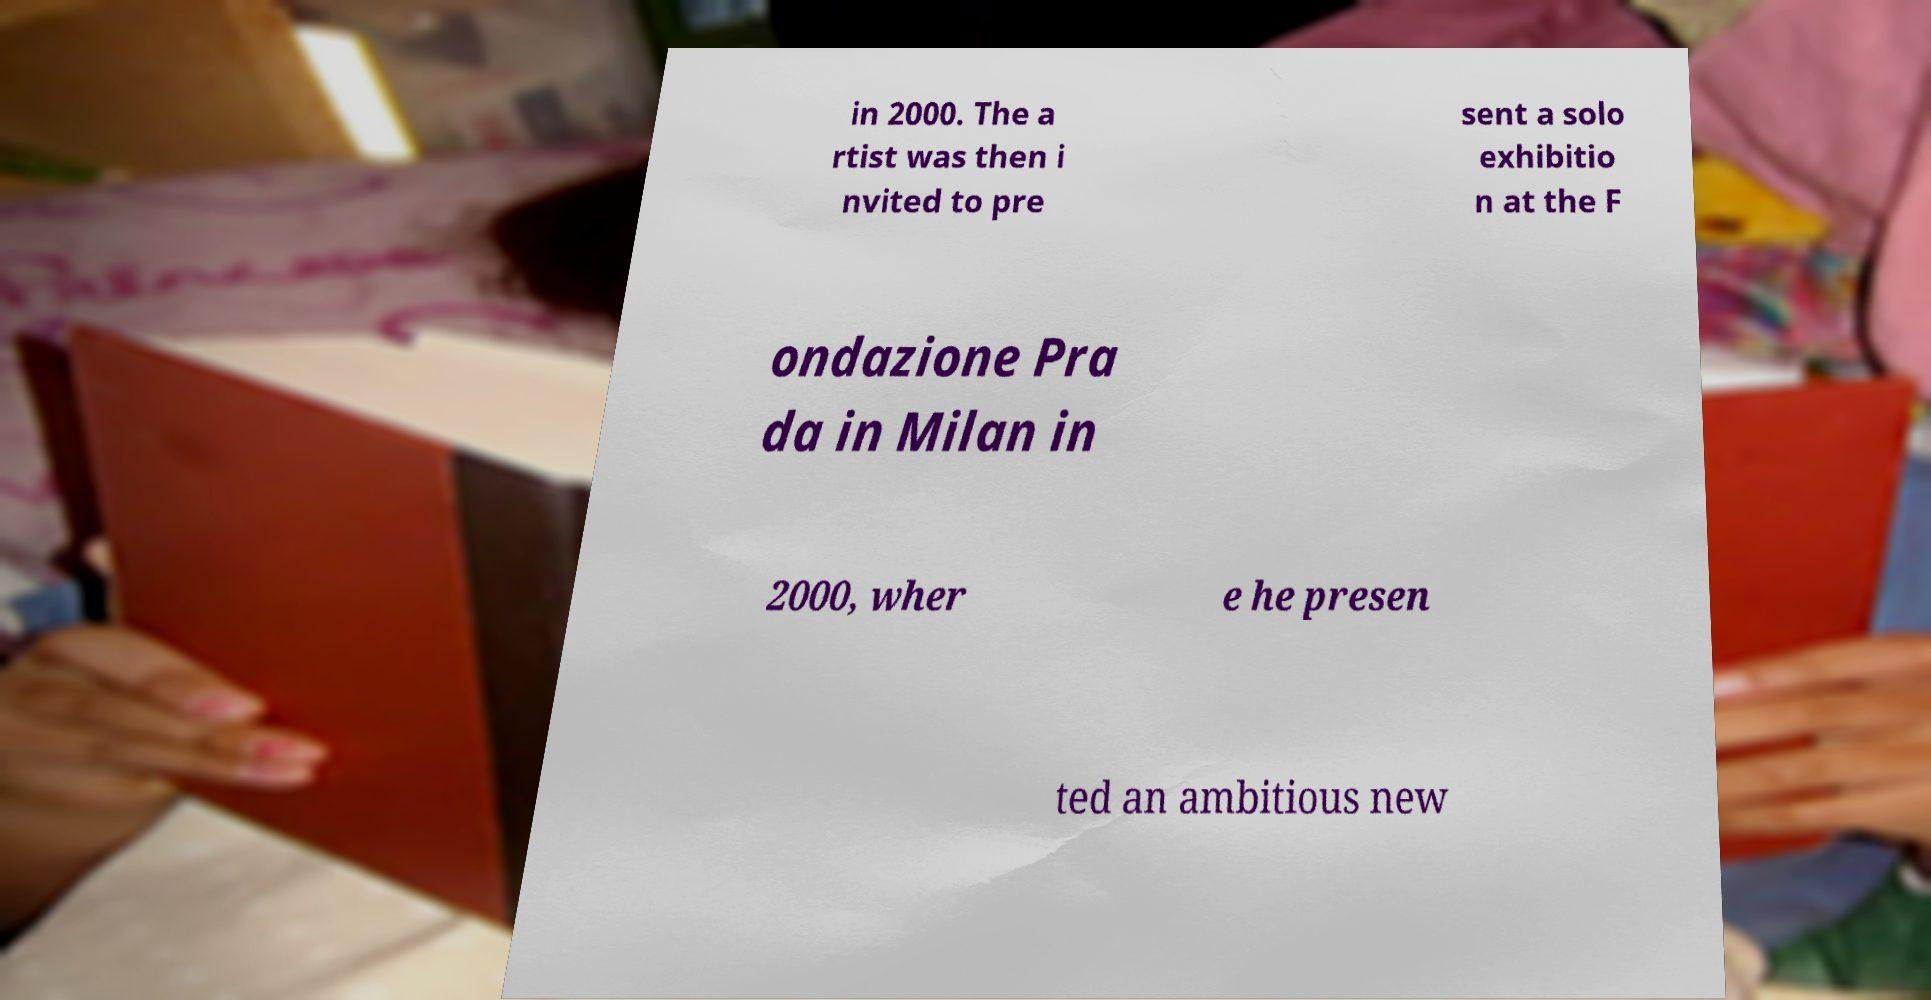For documentation purposes, I need the text within this image transcribed. Could you provide that? in 2000. The a rtist was then i nvited to pre sent a solo exhibitio n at the F ondazione Pra da in Milan in 2000, wher e he presen ted an ambitious new 